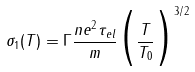Convert formula to latex. <formula><loc_0><loc_0><loc_500><loc_500>\sigma _ { 1 } ( T ) = \Gamma \frac { n e ^ { 2 } \tau _ { e l } } { m } \Big { ( } \frac { T } { T _ { 0 } } \Big { ) } ^ { 3 / 2 }</formula> 